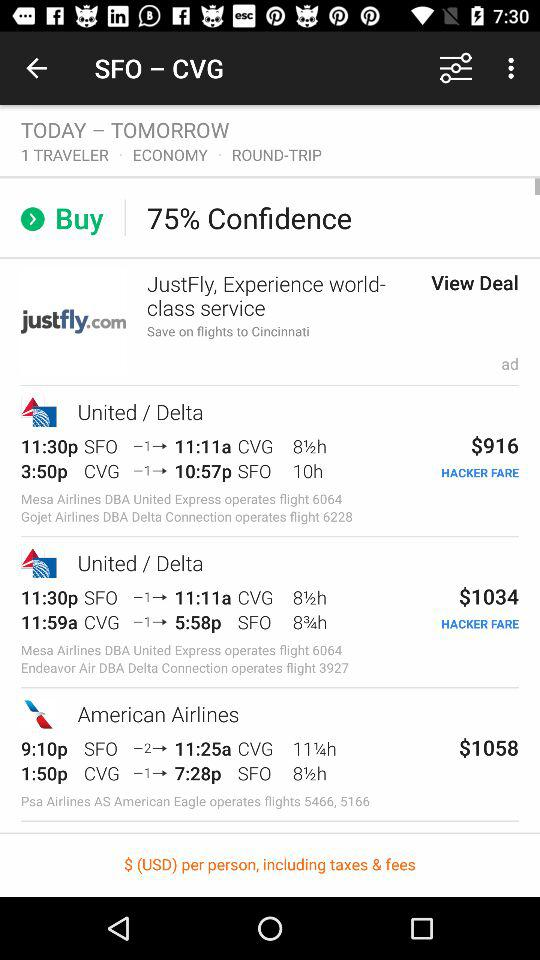What is the difference in price between the first and second flights?
Answer the question using a single word or phrase. $118 